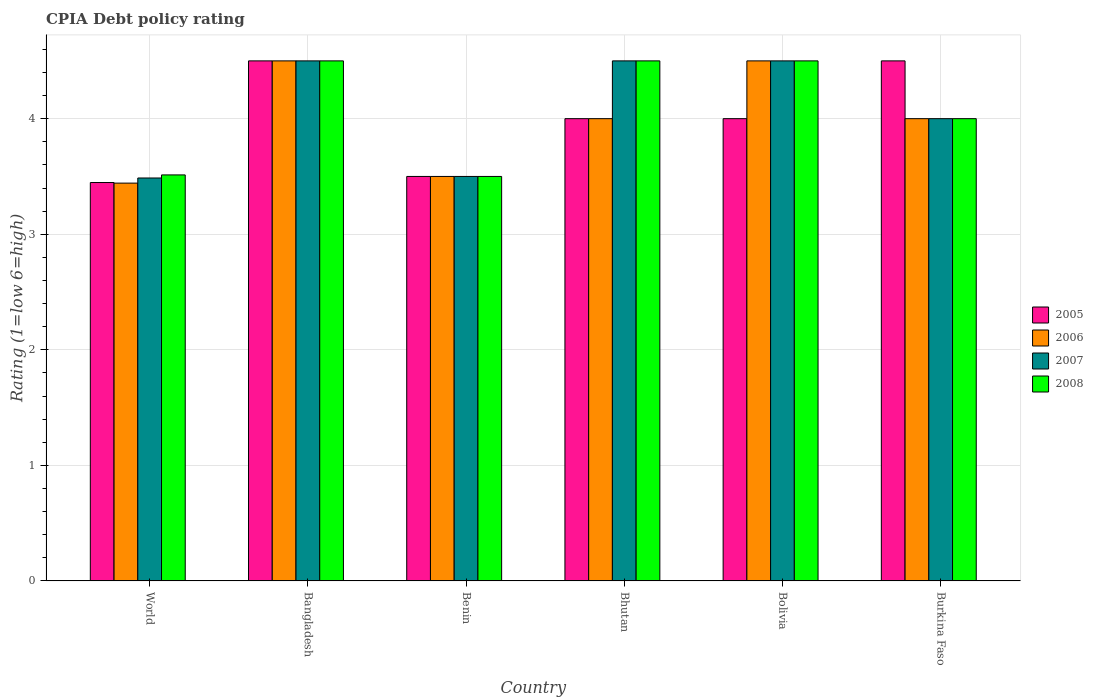How many different coloured bars are there?
Your answer should be very brief. 4. How many groups of bars are there?
Your answer should be compact. 6. Are the number of bars per tick equal to the number of legend labels?
Your answer should be very brief. Yes. Are the number of bars on each tick of the X-axis equal?
Ensure brevity in your answer.  Yes. How many bars are there on the 2nd tick from the left?
Make the answer very short. 4. What is the label of the 4th group of bars from the left?
Your answer should be compact. Bhutan. In how many cases, is the number of bars for a given country not equal to the number of legend labels?
Offer a terse response. 0. What is the CPIA rating in 2008 in Bangladesh?
Offer a very short reply. 4.5. Across all countries, what is the minimum CPIA rating in 2007?
Your answer should be compact. 3.49. In which country was the CPIA rating in 2006 maximum?
Provide a succinct answer. Bangladesh. In which country was the CPIA rating in 2008 minimum?
Offer a very short reply. Benin. What is the total CPIA rating in 2008 in the graph?
Your answer should be compact. 24.51. What is the difference between the CPIA rating in 2006 in Bangladesh and that in World?
Offer a terse response. 1.06. What is the average CPIA rating in 2007 per country?
Give a very brief answer. 4.08. What is the difference between the CPIA rating of/in 2008 and CPIA rating of/in 2006 in Burkina Faso?
Your response must be concise. 0. What is the ratio of the CPIA rating in 2008 in Bhutan to that in World?
Your answer should be compact. 1.28. Is the difference between the CPIA rating in 2008 in Bangladesh and Bhutan greater than the difference between the CPIA rating in 2006 in Bangladesh and Bhutan?
Provide a short and direct response. No. What is the difference between the highest and the second highest CPIA rating in 2006?
Make the answer very short. 0.5. What is the difference between the highest and the lowest CPIA rating in 2005?
Provide a short and direct response. 1.05. Is it the case that in every country, the sum of the CPIA rating in 2005 and CPIA rating in 2007 is greater than the CPIA rating in 2008?
Make the answer very short. Yes. What is the difference between two consecutive major ticks on the Y-axis?
Your answer should be compact. 1. Does the graph contain grids?
Offer a terse response. Yes. What is the title of the graph?
Give a very brief answer. CPIA Debt policy rating. Does "1969" appear as one of the legend labels in the graph?
Your answer should be very brief. No. What is the Rating (1=low 6=high) in 2005 in World?
Provide a succinct answer. 3.45. What is the Rating (1=low 6=high) in 2006 in World?
Offer a very short reply. 3.44. What is the Rating (1=low 6=high) of 2007 in World?
Ensure brevity in your answer.  3.49. What is the Rating (1=low 6=high) of 2008 in World?
Your response must be concise. 3.51. What is the Rating (1=low 6=high) in 2005 in Bangladesh?
Ensure brevity in your answer.  4.5. What is the Rating (1=low 6=high) of 2006 in Bangladesh?
Your answer should be very brief. 4.5. What is the Rating (1=low 6=high) in 2007 in Bangladesh?
Offer a terse response. 4.5. What is the Rating (1=low 6=high) of 2008 in Bangladesh?
Ensure brevity in your answer.  4.5. What is the Rating (1=low 6=high) of 2005 in Benin?
Provide a short and direct response. 3.5. What is the Rating (1=low 6=high) in 2007 in Benin?
Ensure brevity in your answer.  3.5. What is the Rating (1=low 6=high) in 2008 in Benin?
Your answer should be very brief. 3.5. What is the Rating (1=low 6=high) in 2005 in Bhutan?
Your answer should be very brief. 4. What is the Rating (1=low 6=high) of 2007 in Bhutan?
Provide a short and direct response. 4.5. What is the Rating (1=low 6=high) of 2007 in Bolivia?
Your answer should be compact. 4.5. What is the Rating (1=low 6=high) in 2008 in Bolivia?
Give a very brief answer. 4.5. What is the Rating (1=low 6=high) in 2005 in Burkina Faso?
Ensure brevity in your answer.  4.5. What is the Rating (1=low 6=high) in 2006 in Burkina Faso?
Provide a short and direct response. 4. What is the Rating (1=low 6=high) of 2007 in Burkina Faso?
Ensure brevity in your answer.  4. What is the Rating (1=low 6=high) in 2008 in Burkina Faso?
Ensure brevity in your answer.  4. Across all countries, what is the maximum Rating (1=low 6=high) of 2008?
Offer a terse response. 4.5. Across all countries, what is the minimum Rating (1=low 6=high) in 2005?
Ensure brevity in your answer.  3.45. Across all countries, what is the minimum Rating (1=low 6=high) of 2006?
Offer a terse response. 3.44. Across all countries, what is the minimum Rating (1=low 6=high) in 2007?
Provide a succinct answer. 3.49. Across all countries, what is the minimum Rating (1=low 6=high) in 2008?
Keep it short and to the point. 3.5. What is the total Rating (1=low 6=high) of 2005 in the graph?
Your answer should be compact. 23.95. What is the total Rating (1=low 6=high) in 2006 in the graph?
Provide a short and direct response. 23.94. What is the total Rating (1=low 6=high) in 2007 in the graph?
Offer a very short reply. 24.49. What is the total Rating (1=low 6=high) in 2008 in the graph?
Your answer should be compact. 24.51. What is the difference between the Rating (1=low 6=high) of 2005 in World and that in Bangladesh?
Provide a succinct answer. -1.05. What is the difference between the Rating (1=low 6=high) of 2006 in World and that in Bangladesh?
Make the answer very short. -1.06. What is the difference between the Rating (1=low 6=high) of 2007 in World and that in Bangladesh?
Give a very brief answer. -1.01. What is the difference between the Rating (1=low 6=high) in 2008 in World and that in Bangladesh?
Your answer should be very brief. -0.99. What is the difference between the Rating (1=low 6=high) in 2005 in World and that in Benin?
Your response must be concise. -0.05. What is the difference between the Rating (1=low 6=high) of 2006 in World and that in Benin?
Ensure brevity in your answer.  -0.06. What is the difference between the Rating (1=low 6=high) in 2007 in World and that in Benin?
Provide a short and direct response. -0.01. What is the difference between the Rating (1=low 6=high) in 2008 in World and that in Benin?
Provide a succinct answer. 0.01. What is the difference between the Rating (1=low 6=high) of 2005 in World and that in Bhutan?
Offer a very short reply. -0.55. What is the difference between the Rating (1=low 6=high) of 2006 in World and that in Bhutan?
Provide a succinct answer. -0.56. What is the difference between the Rating (1=low 6=high) of 2007 in World and that in Bhutan?
Ensure brevity in your answer.  -1.01. What is the difference between the Rating (1=low 6=high) in 2008 in World and that in Bhutan?
Your response must be concise. -0.99. What is the difference between the Rating (1=low 6=high) in 2005 in World and that in Bolivia?
Provide a succinct answer. -0.55. What is the difference between the Rating (1=low 6=high) in 2006 in World and that in Bolivia?
Your answer should be compact. -1.06. What is the difference between the Rating (1=low 6=high) of 2007 in World and that in Bolivia?
Provide a succinct answer. -1.01. What is the difference between the Rating (1=low 6=high) in 2008 in World and that in Bolivia?
Provide a short and direct response. -0.99. What is the difference between the Rating (1=low 6=high) in 2005 in World and that in Burkina Faso?
Your answer should be compact. -1.05. What is the difference between the Rating (1=low 6=high) in 2006 in World and that in Burkina Faso?
Offer a terse response. -0.56. What is the difference between the Rating (1=low 6=high) in 2007 in World and that in Burkina Faso?
Offer a terse response. -0.51. What is the difference between the Rating (1=low 6=high) of 2008 in World and that in Burkina Faso?
Your answer should be very brief. -0.49. What is the difference between the Rating (1=low 6=high) in 2005 in Bangladesh and that in Benin?
Your answer should be very brief. 1. What is the difference between the Rating (1=low 6=high) in 2007 in Bangladesh and that in Benin?
Keep it short and to the point. 1. What is the difference between the Rating (1=low 6=high) in 2007 in Bangladesh and that in Bhutan?
Provide a succinct answer. 0. What is the difference between the Rating (1=low 6=high) of 2005 in Bangladesh and that in Bolivia?
Provide a succinct answer. 0.5. What is the difference between the Rating (1=low 6=high) of 2007 in Bangladesh and that in Bolivia?
Provide a succinct answer. 0. What is the difference between the Rating (1=low 6=high) of 2005 in Bangladesh and that in Burkina Faso?
Make the answer very short. 0. What is the difference between the Rating (1=low 6=high) in 2006 in Bangladesh and that in Burkina Faso?
Provide a short and direct response. 0.5. What is the difference between the Rating (1=low 6=high) of 2006 in Benin and that in Bhutan?
Give a very brief answer. -0.5. What is the difference between the Rating (1=low 6=high) in 2007 in Benin and that in Bhutan?
Make the answer very short. -1. What is the difference between the Rating (1=low 6=high) in 2008 in Benin and that in Bhutan?
Ensure brevity in your answer.  -1. What is the difference between the Rating (1=low 6=high) in 2007 in Benin and that in Bolivia?
Your answer should be compact. -1. What is the difference between the Rating (1=low 6=high) of 2008 in Benin and that in Bolivia?
Offer a terse response. -1. What is the difference between the Rating (1=low 6=high) in 2007 in Benin and that in Burkina Faso?
Ensure brevity in your answer.  -0.5. What is the difference between the Rating (1=low 6=high) of 2008 in Benin and that in Burkina Faso?
Offer a terse response. -0.5. What is the difference between the Rating (1=low 6=high) of 2008 in Bhutan and that in Bolivia?
Your answer should be compact. 0. What is the difference between the Rating (1=low 6=high) in 2006 in Bhutan and that in Burkina Faso?
Your answer should be compact. 0. What is the difference between the Rating (1=low 6=high) in 2007 in Bhutan and that in Burkina Faso?
Offer a terse response. 0.5. What is the difference between the Rating (1=low 6=high) of 2006 in Bolivia and that in Burkina Faso?
Ensure brevity in your answer.  0.5. What is the difference between the Rating (1=low 6=high) in 2007 in Bolivia and that in Burkina Faso?
Provide a short and direct response. 0.5. What is the difference between the Rating (1=low 6=high) of 2005 in World and the Rating (1=low 6=high) of 2006 in Bangladesh?
Offer a very short reply. -1.05. What is the difference between the Rating (1=low 6=high) of 2005 in World and the Rating (1=low 6=high) of 2007 in Bangladesh?
Your answer should be compact. -1.05. What is the difference between the Rating (1=low 6=high) in 2005 in World and the Rating (1=low 6=high) in 2008 in Bangladesh?
Your answer should be very brief. -1.05. What is the difference between the Rating (1=low 6=high) of 2006 in World and the Rating (1=low 6=high) of 2007 in Bangladesh?
Ensure brevity in your answer.  -1.06. What is the difference between the Rating (1=low 6=high) of 2006 in World and the Rating (1=low 6=high) of 2008 in Bangladesh?
Offer a terse response. -1.06. What is the difference between the Rating (1=low 6=high) of 2007 in World and the Rating (1=low 6=high) of 2008 in Bangladesh?
Provide a succinct answer. -1.01. What is the difference between the Rating (1=low 6=high) in 2005 in World and the Rating (1=low 6=high) in 2006 in Benin?
Provide a short and direct response. -0.05. What is the difference between the Rating (1=low 6=high) in 2005 in World and the Rating (1=low 6=high) in 2007 in Benin?
Make the answer very short. -0.05. What is the difference between the Rating (1=low 6=high) of 2005 in World and the Rating (1=low 6=high) of 2008 in Benin?
Offer a terse response. -0.05. What is the difference between the Rating (1=low 6=high) of 2006 in World and the Rating (1=low 6=high) of 2007 in Benin?
Ensure brevity in your answer.  -0.06. What is the difference between the Rating (1=low 6=high) in 2006 in World and the Rating (1=low 6=high) in 2008 in Benin?
Offer a terse response. -0.06. What is the difference between the Rating (1=low 6=high) in 2007 in World and the Rating (1=low 6=high) in 2008 in Benin?
Ensure brevity in your answer.  -0.01. What is the difference between the Rating (1=low 6=high) in 2005 in World and the Rating (1=low 6=high) in 2006 in Bhutan?
Provide a succinct answer. -0.55. What is the difference between the Rating (1=low 6=high) of 2005 in World and the Rating (1=low 6=high) of 2007 in Bhutan?
Keep it short and to the point. -1.05. What is the difference between the Rating (1=low 6=high) of 2005 in World and the Rating (1=low 6=high) of 2008 in Bhutan?
Your answer should be very brief. -1.05. What is the difference between the Rating (1=low 6=high) of 2006 in World and the Rating (1=low 6=high) of 2007 in Bhutan?
Your answer should be compact. -1.06. What is the difference between the Rating (1=low 6=high) in 2006 in World and the Rating (1=low 6=high) in 2008 in Bhutan?
Your answer should be compact. -1.06. What is the difference between the Rating (1=low 6=high) of 2007 in World and the Rating (1=low 6=high) of 2008 in Bhutan?
Give a very brief answer. -1.01. What is the difference between the Rating (1=low 6=high) in 2005 in World and the Rating (1=low 6=high) in 2006 in Bolivia?
Offer a very short reply. -1.05. What is the difference between the Rating (1=low 6=high) in 2005 in World and the Rating (1=low 6=high) in 2007 in Bolivia?
Offer a terse response. -1.05. What is the difference between the Rating (1=low 6=high) in 2005 in World and the Rating (1=low 6=high) in 2008 in Bolivia?
Your response must be concise. -1.05. What is the difference between the Rating (1=low 6=high) of 2006 in World and the Rating (1=low 6=high) of 2007 in Bolivia?
Your answer should be very brief. -1.06. What is the difference between the Rating (1=low 6=high) of 2006 in World and the Rating (1=low 6=high) of 2008 in Bolivia?
Give a very brief answer. -1.06. What is the difference between the Rating (1=low 6=high) in 2007 in World and the Rating (1=low 6=high) in 2008 in Bolivia?
Keep it short and to the point. -1.01. What is the difference between the Rating (1=low 6=high) of 2005 in World and the Rating (1=low 6=high) of 2006 in Burkina Faso?
Provide a short and direct response. -0.55. What is the difference between the Rating (1=low 6=high) in 2005 in World and the Rating (1=low 6=high) in 2007 in Burkina Faso?
Offer a very short reply. -0.55. What is the difference between the Rating (1=low 6=high) in 2005 in World and the Rating (1=low 6=high) in 2008 in Burkina Faso?
Your response must be concise. -0.55. What is the difference between the Rating (1=low 6=high) in 2006 in World and the Rating (1=low 6=high) in 2007 in Burkina Faso?
Give a very brief answer. -0.56. What is the difference between the Rating (1=low 6=high) in 2006 in World and the Rating (1=low 6=high) in 2008 in Burkina Faso?
Provide a succinct answer. -0.56. What is the difference between the Rating (1=low 6=high) in 2007 in World and the Rating (1=low 6=high) in 2008 in Burkina Faso?
Give a very brief answer. -0.51. What is the difference between the Rating (1=low 6=high) in 2005 in Bangladesh and the Rating (1=low 6=high) in 2007 in Benin?
Keep it short and to the point. 1. What is the difference between the Rating (1=low 6=high) of 2005 in Bangladesh and the Rating (1=low 6=high) of 2008 in Benin?
Offer a very short reply. 1. What is the difference between the Rating (1=low 6=high) in 2007 in Bangladesh and the Rating (1=low 6=high) in 2008 in Benin?
Offer a terse response. 1. What is the difference between the Rating (1=low 6=high) of 2005 in Bangladesh and the Rating (1=low 6=high) of 2007 in Bhutan?
Provide a short and direct response. 0. What is the difference between the Rating (1=low 6=high) in 2005 in Bangladesh and the Rating (1=low 6=high) in 2008 in Bhutan?
Provide a short and direct response. 0. What is the difference between the Rating (1=low 6=high) in 2006 in Bangladesh and the Rating (1=low 6=high) in 2007 in Bhutan?
Give a very brief answer. 0. What is the difference between the Rating (1=low 6=high) in 2007 in Bangladesh and the Rating (1=low 6=high) in 2008 in Bhutan?
Your response must be concise. 0. What is the difference between the Rating (1=low 6=high) of 2005 in Bangladesh and the Rating (1=low 6=high) of 2006 in Bolivia?
Ensure brevity in your answer.  0. What is the difference between the Rating (1=low 6=high) of 2005 in Bangladesh and the Rating (1=low 6=high) of 2007 in Bolivia?
Your response must be concise. 0. What is the difference between the Rating (1=low 6=high) of 2005 in Bangladesh and the Rating (1=low 6=high) of 2008 in Bolivia?
Keep it short and to the point. 0. What is the difference between the Rating (1=low 6=high) in 2006 in Bangladesh and the Rating (1=low 6=high) in 2008 in Bolivia?
Your answer should be compact. 0. What is the difference between the Rating (1=low 6=high) in 2007 in Bangladesh and the Rating (1=low 6=high) in 2008 in Bolivia?
Offer a very short reply. 0. What is the difference between the Rating (1=low 6=high) in 2005 in Bangladesh and the Rating (1=low 6=high) in 2006 in Burkina Faso?
Keep it short and to the point. 0.5. What is the difference between the Rating (1=low 6=high) of 2005 in Benin and the Rating (1=low 6=high) of 2007 in Bhutan?
Keep it short and to the point. -1. What is the difference between the Rating (1=low 6=high) in 2005 in Benin and the Rating (1=low 6=high) in 2008 in Bhutan?
Offer a terse response. -1. What is the difference between the Rating (1=low 6=high) in 2006 in Benin and the Rating (1=low 6=high) in 2008 in Bhutan?
Provide a succinct answer. -1. What is the difference between the Rating (1=low 6=high) of 2007 in Benin and the Rating (1=low 6=high) of 2008 in Bhutan?
Provide a short and direct response. -1. What is the difference between the Rating (1=low 6=high) of 2007 in Benin and the Rating (1=low 6=high) of 2008 in Bolivia?
Make the answer very short. -1. What is the difference between the Rating (1=low 6=high) in 2005 in Benin and the Rating (1=low 6=high) in 2006 in Burkina Faso?
Provide a short and direct response. -0.5. What is the difference between the Rating (1=low 6=high) in 2005 in Benin and the Rating (1=low 6=high) in 2008 in Burkina Faso?
Ensure brevity in your answer.  -0.5. What is the difference between the Rating (1=low 6=high) in 2006 in Benin and the Rating (1=low 6=high) in 2008 in Burkina Faso?
Your response must be concise. -0.5. What is the difference between the Rating (1=low 6=high) in 2007 in Benin and the Rating (1=low 6=high) in 2008 in Burkina Faso?
Keep it short and to the point. -0.5. What is the difference between the Rating (1=low 6=high) in 2005 in Bhutan and the Rating (1=low 6=high) in 2007 in Bolivia?
Offer a very short reply. -0.5. What is the difference between the Rating (1=low 6=high) of 2005 in Bhutan and the Rating (1=low 6=high) of 2008 in Bolivia?
Provide a succinct answer. -0.5. What is the difference between the Rating (1=low 6=high) in 2005 in Bhutan and the Rating (1=low 6=high) in 2006 in Burkina Faso?
Offer a terse response. 0. What is the difference between the Rating (1=low 6=high) in 2005 in Bhutan and the Rating (1=low 6=high) in 2008 in Burkina Faso?
Make the answer very short. 0. What is the difference between the Rating (1=low 6=high) in 2006 in Bhutan and the Rating (1=low 6=high) in 2007 in Burkina Faso?
Keep it short and to the point. 0. What is the difference between the Rating (1=low 6=high) of 2006 in Bhutan and the Rating (1=low 6=high) of 2008 in Burkina Faso?
Make the answer very short. 0. What is the difference between the Rating (1=low 6=high) of 2005 in Bolivia and the Rating (1=low 6=high) of 2006 in Burkina Faso?
Your answer should be very brief. 0. What is the difference between the Rating (1=low 6=high) in 2005 in Bolivia and the Rating (1=low 6=high) in 2007 in Burkina Faso?
Ensure brevity in your answer.  0. What is the difference between the Rating (1=low 6=high) in 2005 in Bolivia and the Rating (1=low 6=high) in 2008 in Burkina Faso?
Make the answer very short. 0. What is the difference between the Rating (1=low 6=high) in 2006 in Bolivia and the Rating (1=low 6=high) in 2007 in Burkina Faso?
Ensure brevity in your answer.  0.5. What is the difference between the Rating (1=low 6=high) of 2006 in Bolivia and the Rating (1=low 6=high) of 2008 in Burkina Faso?
Make the answer very short. 0.5. What is the average Rating (1=low 6=high) of 2005 per country?
Your answer should be compact. 3.99. What is the average Rating (1=low 6=high) of 2006 per country?
Offer a very short reply. 3.99. What is the average Rating (1=low 6=high) of 2007 per country?
Ensure brevity in your answer.  4.08. What is the average Rating (1=low 6=high) in 2008 per country?
Keep it short and to the point. 4.09. What is the difference between the Rating (1=low 6=high) in 2005 and Rating (1=low 6=high) in 2006 in World?
Keep it short and to the point. 0.01. What is the difference between the Rating (1=low 6=high) of 2005 and Rating (1=low 6=high) of 2007 in World?
Offer a terse response. -0.04. What is the difference between the Rating (1=low 6=high) in 2005 and Rating (1=low 6=high) in 2008 in World?
Your response must be concise. -0.07. What is the difference between the Rating (1=low 6=high) in 2006 and Rating (1=low 6=high) in 2007 in World?
Ensure brevity in your answer.  -0.04. What is the difference between the Rating (1=low 6=high) of 2006 and Rating (1=low 6=high) of 2008 in World?
Your answer should be compact. -0.07. What is the difference between the Rating (1=low 6=high) of 2007 and Rating (1=low 6=high) of 2008 in World?
Give a very brief answer. -0.03. What is the difference between the Rating (1=low 6=high) of 2006 and Rating (1=low 6=high) of 2007 in Bangladesh?
Make the answer very short. 0. What is the difference between the Rating (1=low 6=high) in 2007 and Rating (1=low 6=high) in 2008 in Bangladesh?
Keep it short and to the point. 0. What is the difference between the Rating (1=low 6=high) of 2005 and Rating (1=low 6=high) of 2006 in Benin?
Offer a very short reply. 0. What is the difference between the Rating (1=low 6=high) in 2005 and Rating (1=low 6=high) in 2007 in Benin?
Your answer should be very brief. 0. What is the difference between the Rating (1=low 6=high) of 2005 and Rating (1=low 6=high) of 2008 in Benin?
Provide a short and direct response. 0. What is the difference between the Rating (1=low 6=high) of 2007 and Rating (1=low 6=high) of 2008 in Benin?
Give a very brief answer. 0. What is the difference between the Rating (1=low 6=high) in 2005 and Rating (1=low 6=high) in 2007 in Bhutan?
Provide a short and direct response. -0.5. What is the difference between the Rating (1=low 6=high) of 2006 and Rating (1=low 6=high) of 2007 in Bhutan?
Offer a terse response. -0.5. What is the difference between the Rating (1=low 6=high) in 2007 and Rating (1=low 6=high) in 2008 in Bhutan?
Provide a short and direct response. 0. What is the difference between the Rating (1=low 6=high) in 2006 and Rating (1=low 6=high) in 2008 in Bolivia?
Keep it short and to the point. 0. What is the difference between the Rating (1=low 6=high) in 2005 and Rating (1=low 6=high) in 2006 in Burkina Faso?
Offer a terse response. 0.5. What is the difference between the Rating (1=low 6=high) in 2006 and Rating (1=low 6=high) in 2008 in Burkina Faso?
Your response must be concise. 0. What is the difference between the Rating (1=low 6=high) in 2007 and Rating (1=low 6=high) in 2008 in Burkina Faso?
Keep it short and to the point. 0. What is the ratio of the Rating (1=low 6=high) of 2005 in World to that in Bangladesh?
Your answer should be compact. 0.77. What is the ratio of the Rating (1=low 6=high) in 2006 in World to that in Bangladesh?
Your response must be concise. 0.77. What is the ratio of the Rating (1=low 6=high) in 2007 in World to that in Bangladesh?
Your response must be concise. 0.77. What is the ratio of the Rating (1=low 6=high) of 2008 in World to that in Bangladesh?
Make the answer very short. 0.78. What is the ratio of the Rating (1=low 6=high) in 2005 in World to that in Benin?
Your answer should be very brief. 0.98. What is the ratio of the Rating (1=low 6=high) in 2006 in World to that in Benin?
Your response must be concise. 0.98. What is the ratio of the Rating (1=low 6=high) in 2008 in World to that in Benin?
Your response must be concise. 1. What is the ratio of the Rating (1=low 6=high) in 2005 in World to that in Bhutan?
Your answer should be very brief. 0.86. What is the ratio of the Rating (1=low 6=high) in 2006 in World to that in Bhutan?
Provide a short and direct response. 0.86. What is the ratio of the Rating (1=low 6=high) in 2007 in World to that in Bhutan?
Offer a very short reply. 0.77. What is the ratio of the Rating (1=low 6=high) of 2008 in World to that in Bhutan?
Make the answer very short. 0.78. What is the ratio of the Rating (1=low 6=high) of 2005 in World to that in Bolivia?
Ensure brevity in your answer.  0.86. What is the ratio of the Rating (1=low 6=high) of 2006 in World to that in Bolivia?
Offer a terse response. 0.77. What is the ratio of the Rating (1=low 6=high) of 2007 in World to that in Bolivia?
Ensure brevity in your answer.  0.77. What is the ratio of the Rating (1=low 6=high) of 2008 in World to that in Bolivia?
Offer a very short reply. 0.78. What is the ratio of the Rating (1=low 6=high) in 2005 in World to that in Burkina Faso?
Ensure brevity in your answer.  0.77. What is the ratio of the Rating (1=low 6=high) of 2006 in World to that in Burkina Faso?
Make the answer very short. 0.86. What is the ratio of the Rating (1=low 6=high) of 2007 in World to that in Burkina Faso?
Your answer should be very brief. 0.87. What is the ratio of the Rating (1=low 6=high) of 2008 in World to that in Burkina Faso?
Keep it short and to the point. 0.88. What is the ratio of the Rating (1=low 6=high) in 2005 in Bangladesh to that in Benin?
Offer a terse response. 1.29. What is the ratio of the Rating (1=low 6=high) in 2008 in Bangladesh to that in Benin?
Your response must be concise. 1.29. What is the ratio of the Rating (1=low 6=high) in 2005 in Bangladesh to that in Bhutan?
Ensure brevity in your answer.  1.12. What is the ratio of the Rating (1=low 6=high) of 2006 in Bangladesh to that in Bhutan?
Keep it short and to the point. 1.12. What is the ratio of the Rating (1=low 6=high) of 2007 in Bangladesh to that in Bhutan?
Your response must be concise. 1. What is the ratio of the Rating (1=low 6=high) of 2008 in Bangladesh to that in Bhutan?
Your answer should be compact. 1. What is the ratio of the Rating (1=low 6=high) in 2006 in Bangladesh to that in Bolivia?
Ensure brevity in your answer.  1. What is the ratio of the Rating (1=low 6=high) in 2007 in Bangladesh to that in Bolivia?
Provide a short and direct response. 1. What is the ratio of the Rating (1=low 6=high) of 2005 in Bangladesh to that in Burkina Faso?
Your answer should be very brief. 1. What is the ratio of the Rating (1=low 6=high) of 2007 in Bangladesh to that in Burkina Faso?
Give a very brief answer. 1.12. What is the ratio of the Rating (1=low 6=high) of 2008 in Bangladesh to that in Burkina Faso?
Keep it short and to the point. 1.12. What is the ratio of the Rating (1=low 6=high) of 2005 in Benin to that in Bhutan?
Keep it short and to the point. 0.88. What is the ratio of the Rating (1=low 6=high) of 2006 in Benin to that in Burkina Faso?
Make the answer very short. 0.88. What is the ratio of the Rating (1=low 6=high) of 2007 in Bhutan to that in Bolivia?
Offer a very short reply. 1. What is the ratio of the Rating (1=low 6=high) of 2005 in Bolivia to that in Burkina Faso?
Your response must be concise. 0.89. What is the ratio of the Rating (1=low 6=high) of 2007 in Bolivia to that in Burkina Faso?
Make the answer very short. 1.12. What is the difference between the highest and the second highest Rating (1=low 6=high) in 2008?
Ensure brevity in your answer.  0. What is the difference between the highest and the lowest Rating (1=low 6=high) of 2005?
Offer a very short reply. 1.05. What is the difference between the highest and the lowest Rating (1=low 6=high) in 2006?
Give a very brief answer. 1.06. What is the difference between the highest and the lowest Rating (1=low 6=high) of 2007?
Make the answer very short. 1.01. What is the difference between the highest and the lowest Rating (1=low 6=high) in 2008?
Keep it short and to the point. 1. 